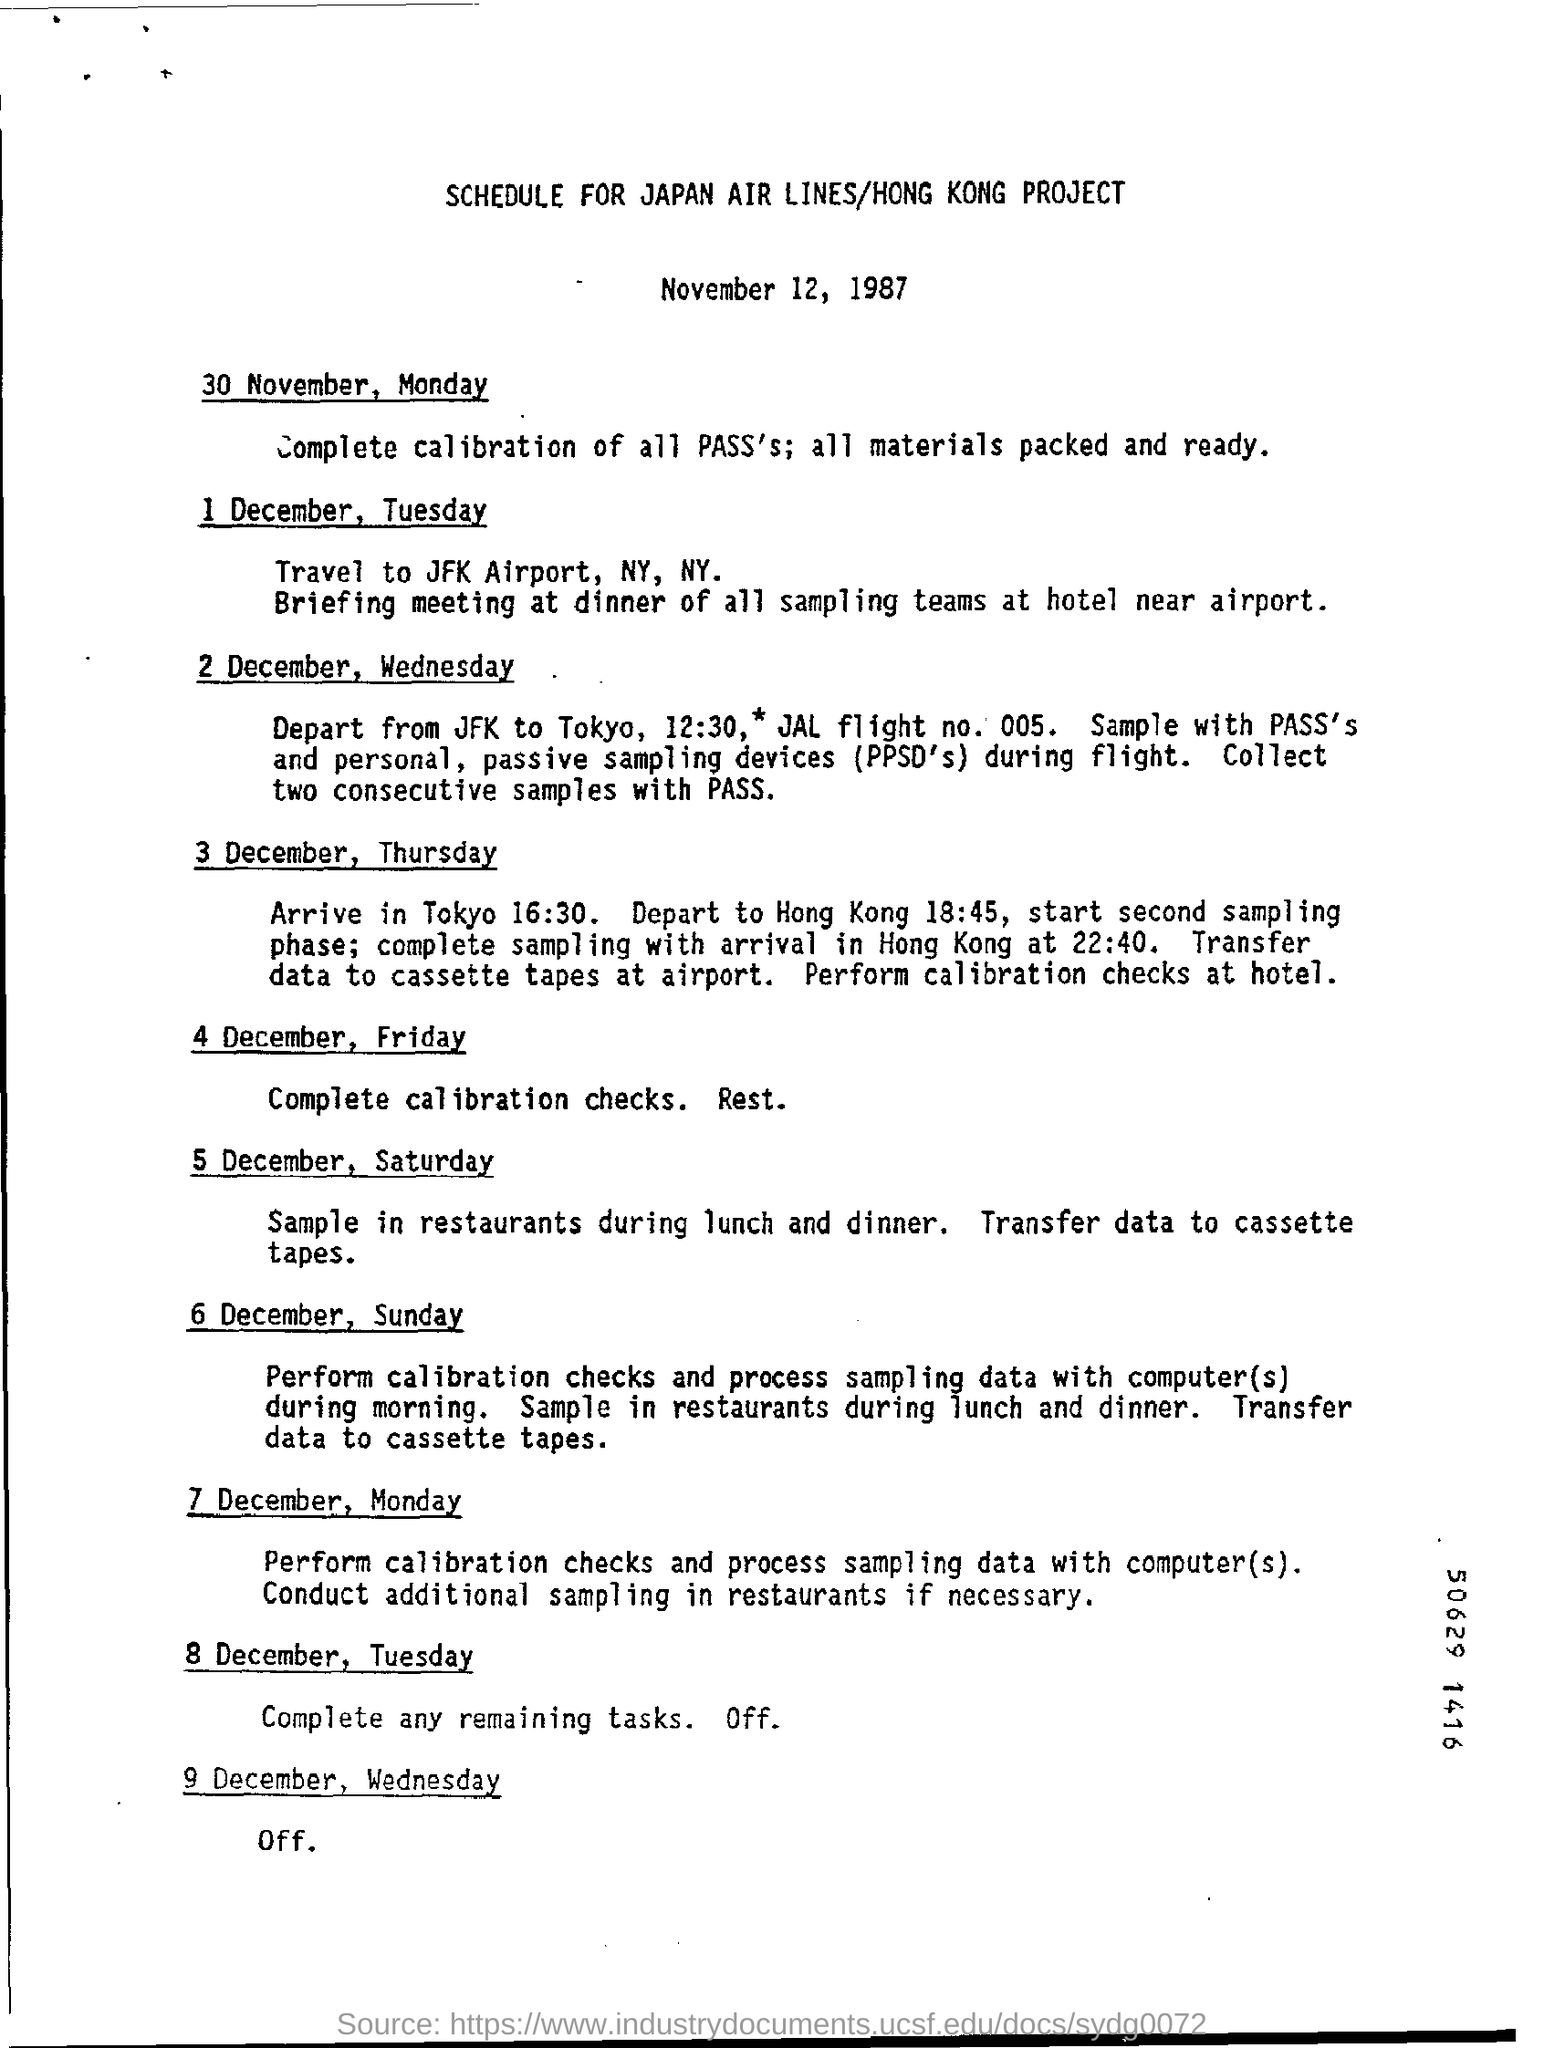What is the title of the given document?
Ensure brevity in your answer.  Schedule for japan air lines/hong kong project. What is the depart time from jfk to tokyo
Give a very brief answer. 12:30. 